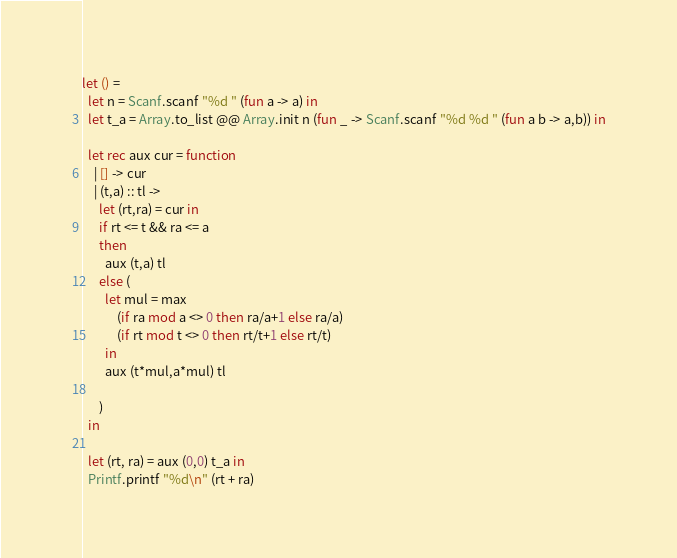Convert code to text. <code><loc_0><loc_0><loc_500><loc_500><_OCaml_>let () =
  let n = Scanf.scanf "%d " (fun a -> a) in
  let t_a = Array.to_list @@ Array.init n (fun _ -> Scanf.scanf "%d %d " (fun a b -> a,b)) in

  let rec aux cur = function
    | [] -> cur 
    | (t,a) :: tl -> 
      let (rt,ra) = cur in
      if rt <= t && ra <= a 
      then 
        aux (t,a) tl
      else (
        let mul = max 
            (if ra mod a <> 0 then ra/a+1 else ra/a) 
            (if rt mod t <> 0 then rt/t+1 else rt/t) 
        in
        aux (t*mul,a*mul) tl

      )
  in

  let (rt, ra) = aux (0,0) t_a in
  Printf.printf "%d\n" (rt + ra)
</code> 